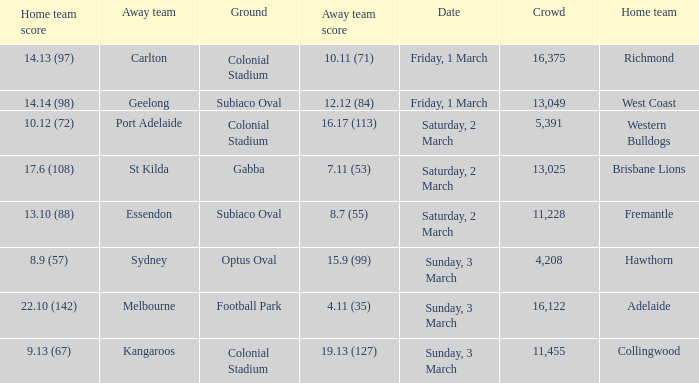What was the ground for away team sydney? Optus Oval. 